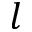Convert formula to latex. <formula><loc_0><loc_0><loc_500><loc_500>l</formula> 